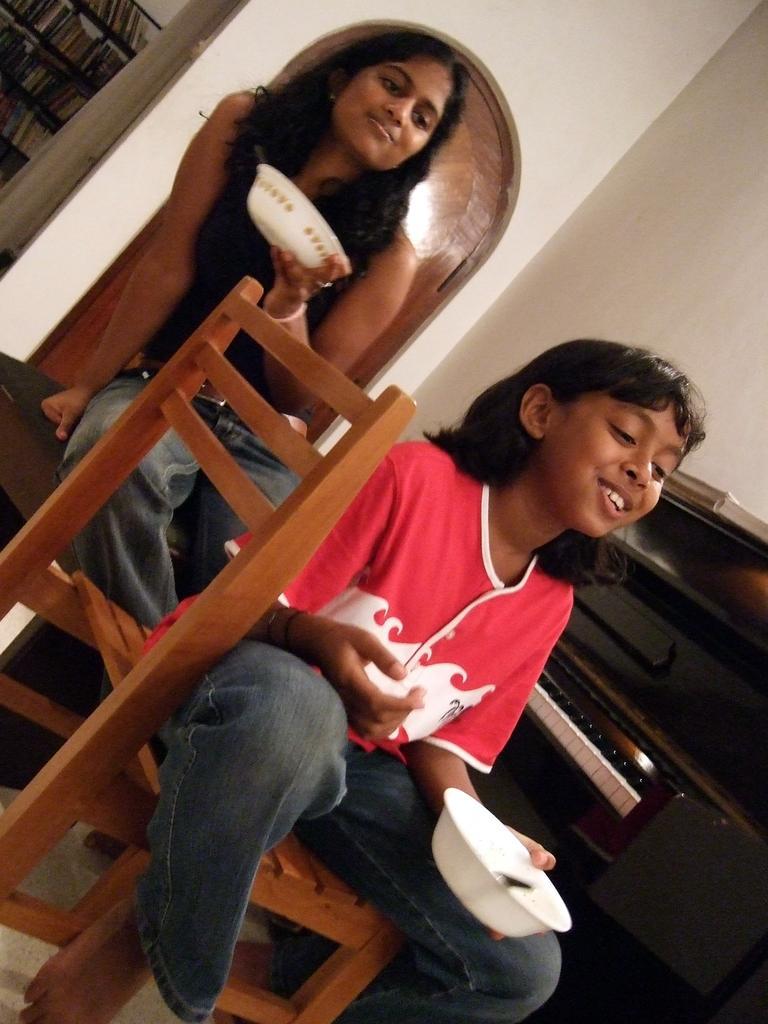How would you summarize this image in a sentence or two? Two girls sitting on the chair sitting in front of a musical instrument holding the bowls. 